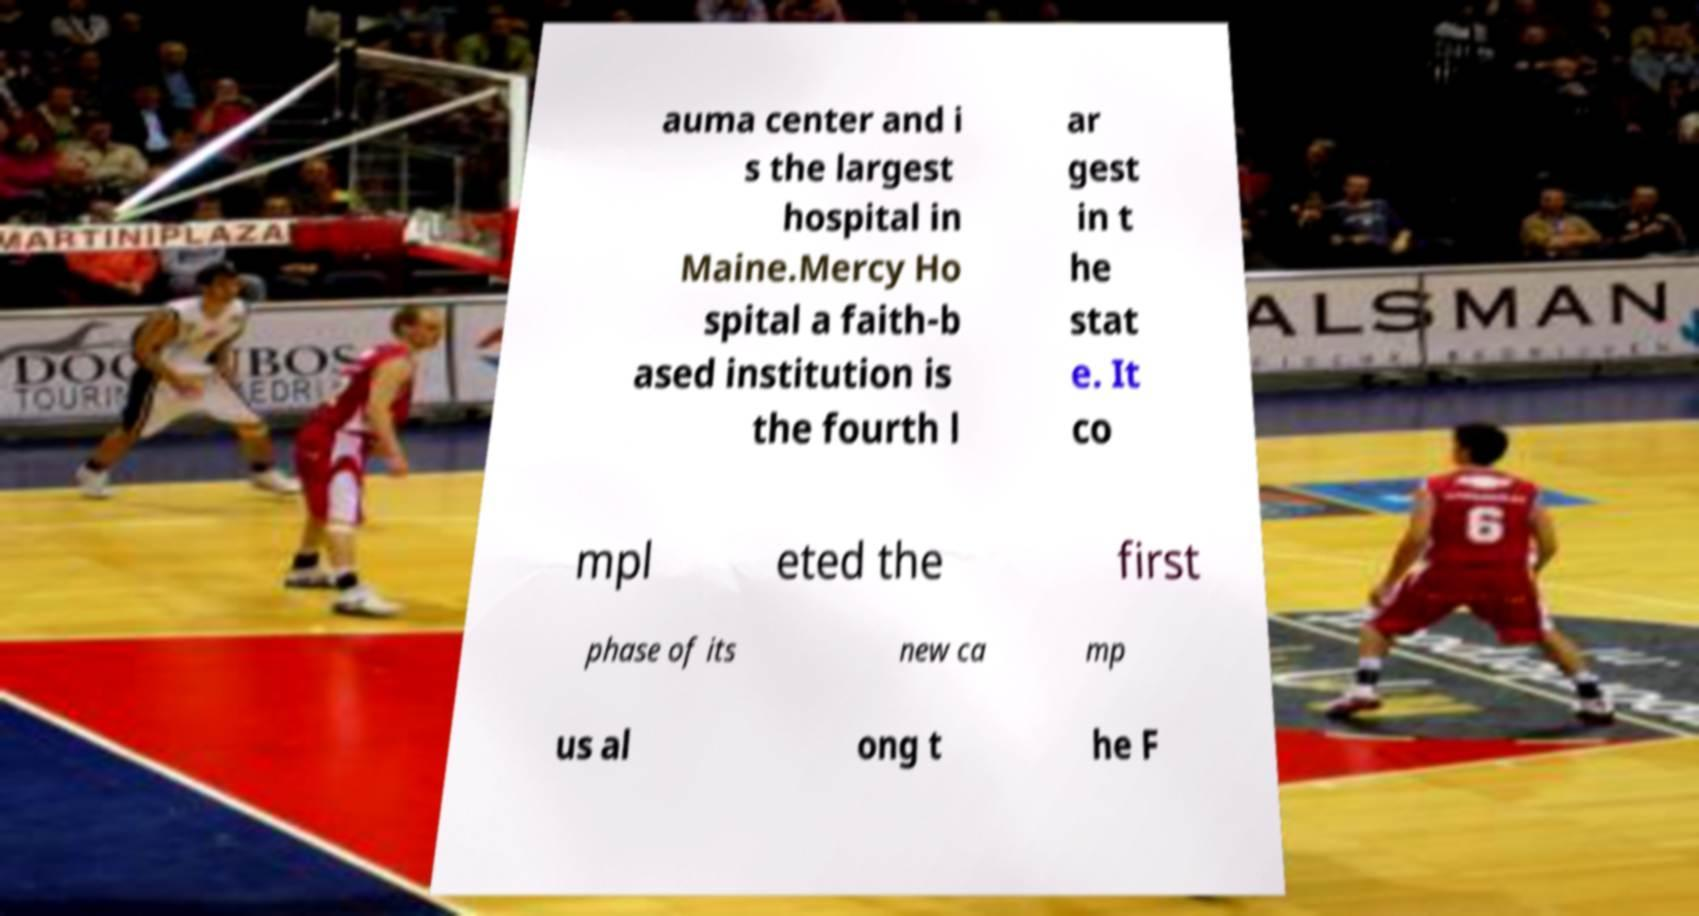There's text embedded in this image that I need extracted. Can you transcribe it verbatim? auma center and i s the largest hospital in Maine.Mercy Ho spital a faith-b ased institution is the fourth l ar gest in t he stat e. It co mpl eted the first phase of its new ca mp us al ong t he F 